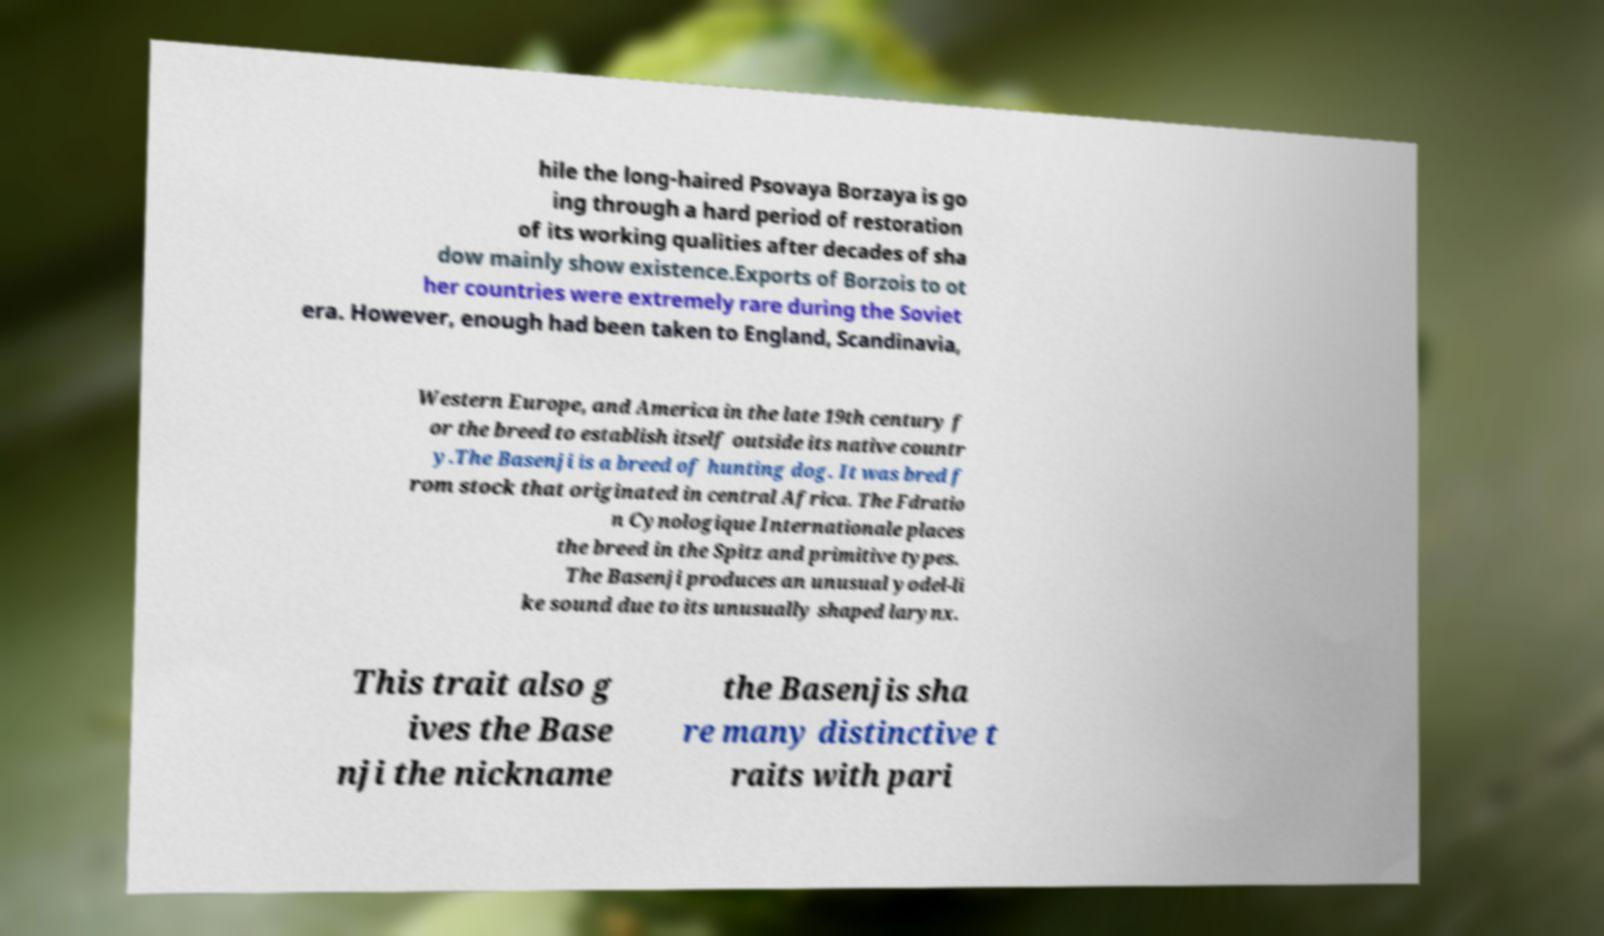Please identify and transcribe the text found in this image. hile the long-haired Psovaya Borzaya is go ing through a hard period of restoration of its working qualities after decades of sha dow mainly show existence.Exports of Borzois to ot her countries were extremely rare during the Soviet era. However, enough had been taken to England, Scandinavia, Western Europe, and America in the late 19th century f or the breed to establish itself outside its native countr y.The Basenji is a breed of hunting dog. It was bred f rom stock that originated in central Africa. The Fdratio n Cynologique Internationale places the breed in the Spitz and primitive types. The Basenji produces an unusual yodel-li ke sound due to its unusually shaped larynx. This trait also g ives the Base nji the nickname the Basenjis sha re many distinctive t raits with pari 